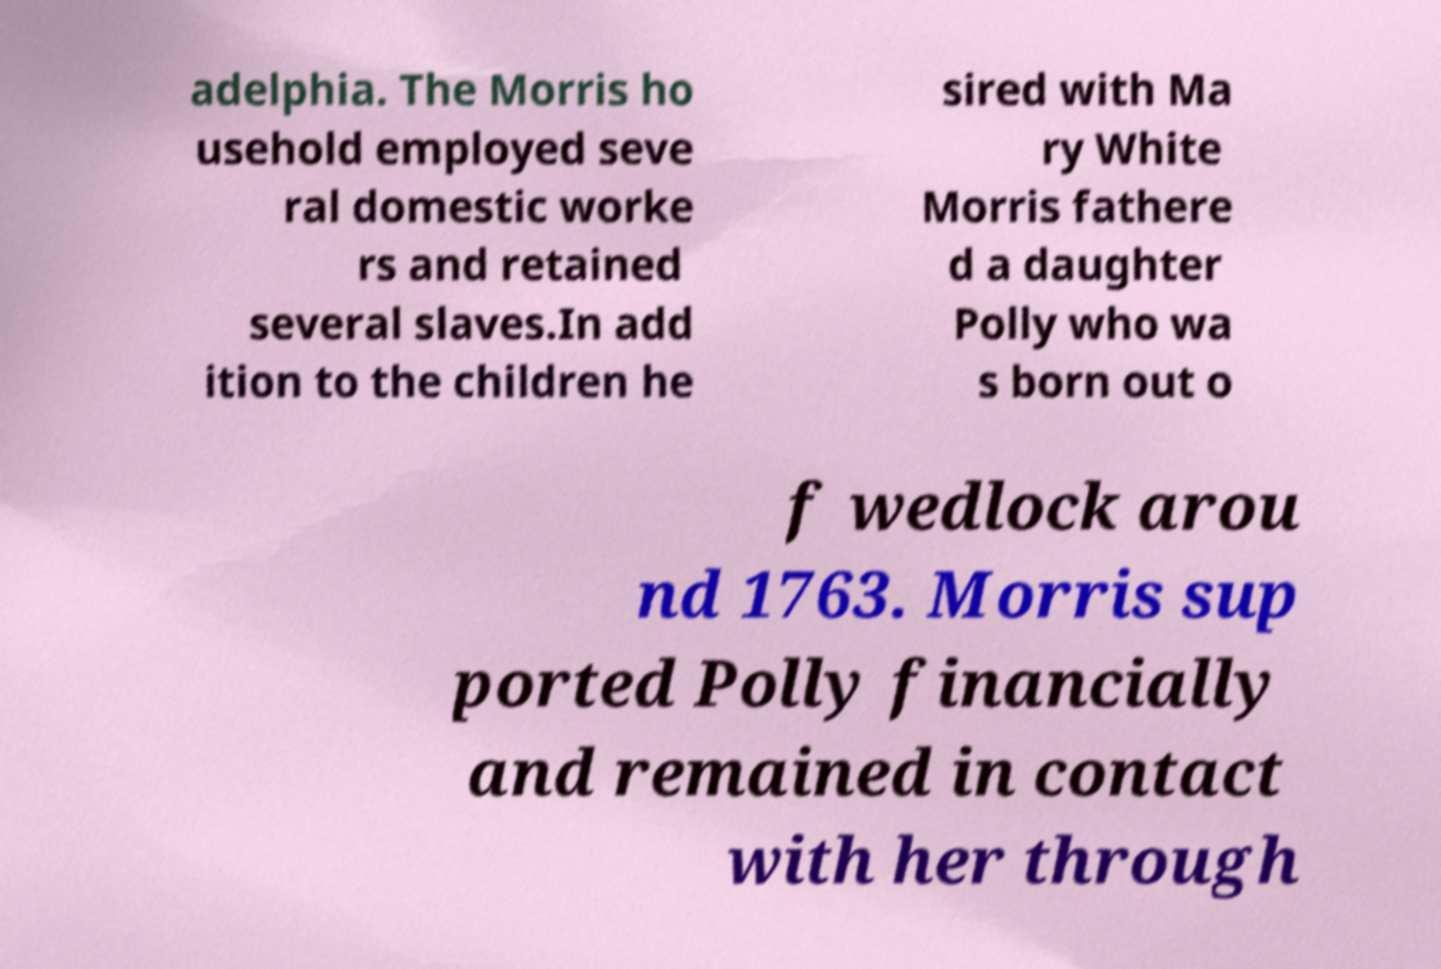I need the written content from this picture converted into text. Can you do that? adelphia. The Morris ho usehold employed seve ral domestic worke rs and retained several slaves.In add ition to the children he sired with Ma ry White Morris fathere d a daughter Polly who wa s born out o f wedlock arou nd 1763. Morris sup ported Polly financially and remained in contact with her through 